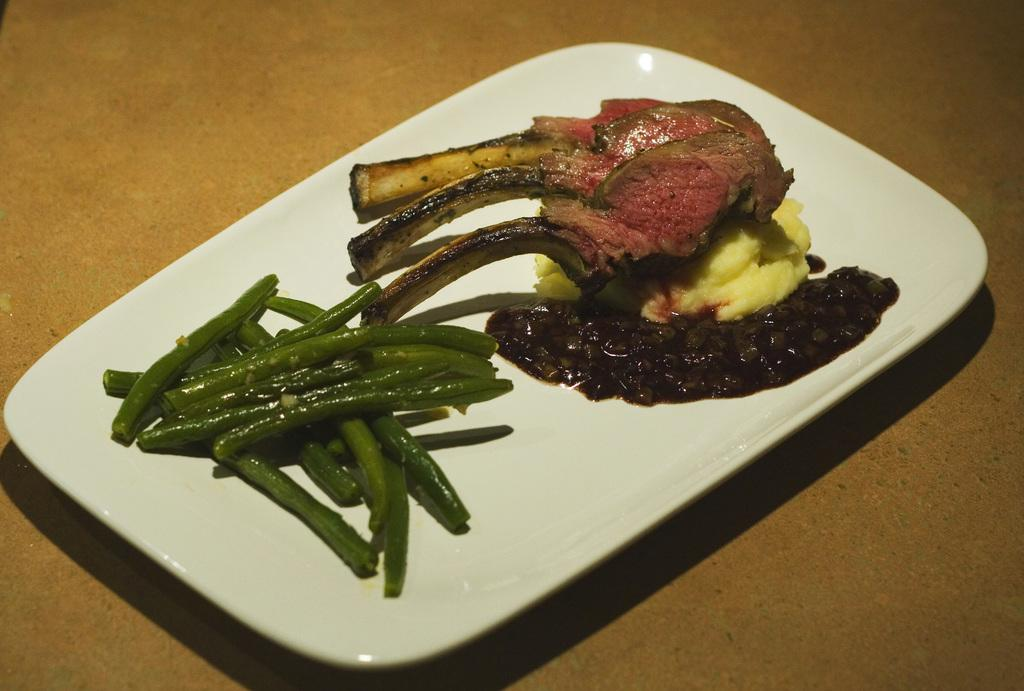What color is the plate that is visible in the image? The plate in the image is white. What is on the plate in the image? There are food items on the plate. How many wrists can be seen holding the plate in the image? There are no wrists visible in the image; only the plate and food items are present. What direction does the plate turn in the image? The plate does not turn in the image; it is stationary. 